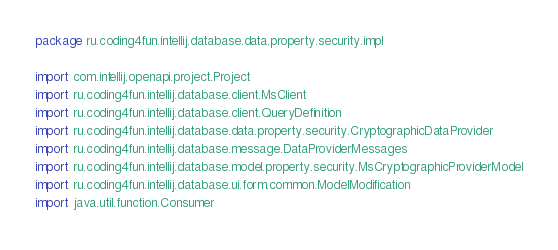<code> <loc_0><loc_0><loc_500><loc_500><_Kotlin_>package ru.coding4fun.intellij.database.data.property.security.impl

import com.intellij.openapi.project.Project
import ru.coding4fun.intellij.database.client.MsClient
import ru.coding4fun.intellij.database.client.QueryDefinition
import ru.coding4fun.intellij.database.data.property.security.CryptographicDataProvider
import ru.coding4fun.intellij.database.message.DataProviderMessages
import ru.coding4fun.intellij.database.model.property.security.MsCryptographicProviderModel
import ru.coding4fun.intellij.database.ui.form.common.ModelModification
import java.util.function.Consumer
</code> 